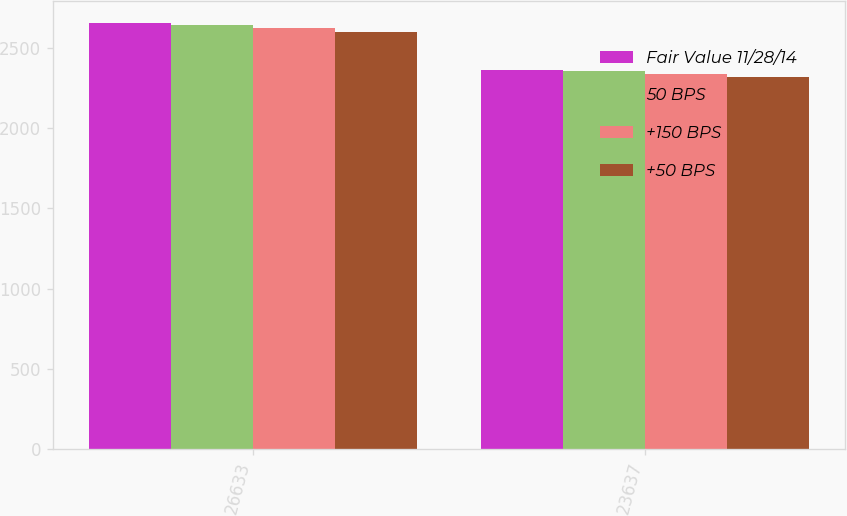Convert chart to OTSL. <chart><loc_0><loc_0><loc_500><loc_500><stacked_bar_chart><ecel><fcel>26633<fcel>23637<nl><fcel>Fair Value 11/28/14<fcel>2656.3<fcel>2360.9<nl><fcel>50 BPS<fcel>2641.9<fcel>2353.8<nl><fcel>+150 BPS<fcel>2621.6<fcel>2338.5<nl><fcel>+50 BPS<fcel>2599.8<fcel>2320.5<nl></chart> 